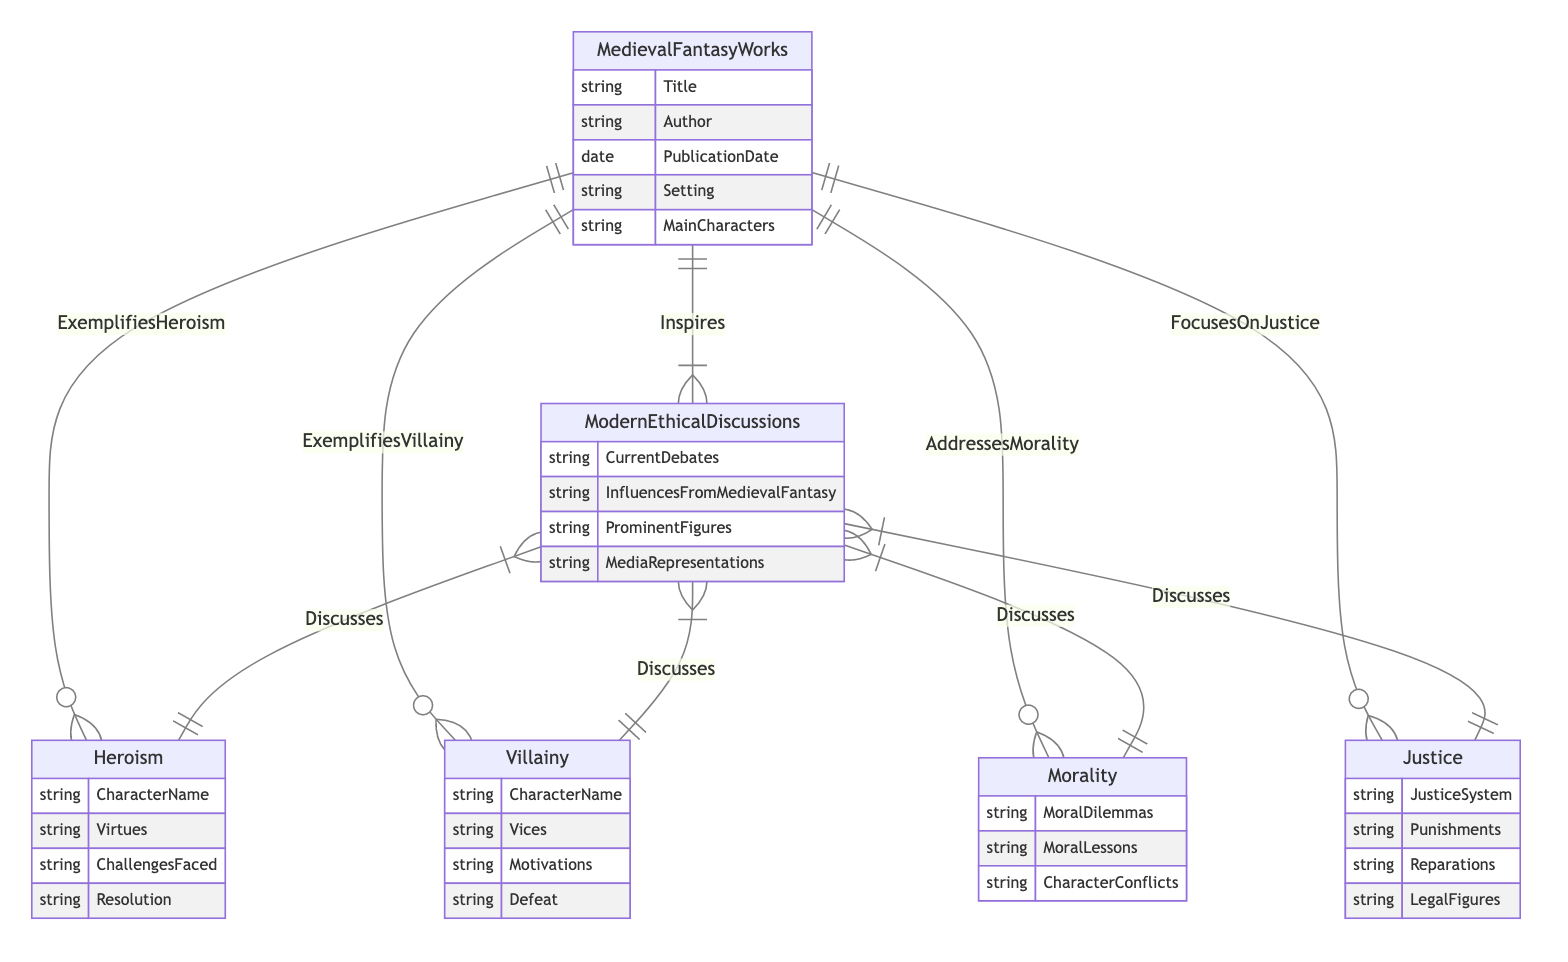What is the primary relationship between Medieval Fantasy Works and Modern Ethical Discussions? The diagram indicates that Medieval Fantasy Works "Inspires" Modern Ethical Discussions, illustrating a direct influence from one to the other.
Answer: Inspires How many attributes are associated with the Villainy entity? According to the diagram, the Villainy entity contains four attributes: CharacterName, Vices, Motivations, and Defeat, giving insight into how villain characters are structured.
Answer: 4 Which entity addresses moral dilemmas in Medieval Fantasy Works? The diagram shows that the Morality entity is connected to Medieval Fantasy Works through the relationship "AddressesMorality," highlighting how these works engage with moral issues.
Answer: Morality What is a theme that Modern Ethical Discussions discusses related to Heroism? Within the relationship identified in the diagram, the Modern Ethical Discussions entity connects to Heroism and involves discussions on Heroism, implying that this theme is a topic of contemporary ethical debate.
Answer: Heroism How many relationships involve the Modern Ethical Discussions entity? The diagram depicts four connections going out from the Modern Ethical Discussions entity, indicating its engagement with Heroism, Villainy, Morality, and Justice.
Answer: 4 What are the attributes of the Justice entity? The diagram lists the attributes of the Justice entity: JusticeSystem, Punishments, Reparations, and LegalFigures, outlining the components that define justice in the context of this analysis.
Answer: JusticeSystem, Punishments, Reparations, LegalFigures What role do Medieval Fantasy Works play in the context of Heroism? The diagram indicates that Medieval Fantasy Works "ExemplifiesHeroism," showcasing their role in portraying heroic characteristics and possibly serving as a model for heroism in modern discussions.
Answer: ExemplifiesHeroism Which character trait is referenced in both Villainy and Heroism entities? The diagram shows that both Villainy and Heroism entities deal with character traits; specifically, Villainy includes vices while Heroism includes virtues, making a contrast between good and evil character traits.
Answer: Character traits What is one of the influences from Medieval Fantasy on Modern Ethical Discussions? The entity Modern Ethical Discussions includes an attribute "InfluencesFromMedievalFantasy" that suggests that there are various ways medieval narratives impact ethical discourse today.
Answer: InfluencesFromMedievalFantasy 